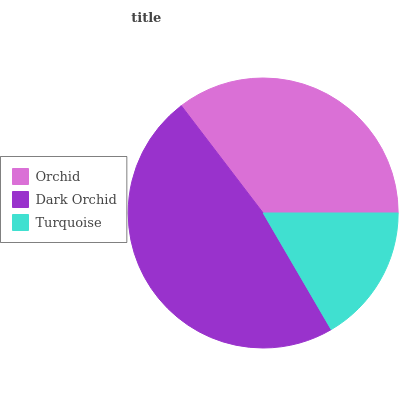Is Turquoise the minimum?
Answer yes or no. Yes. Is Dark Orchid the maximum?
Answer yes or no. Yes. Is Dark Orchid the minimum?
Answer yes or no. No. Is Turquoise the maximum?
Answer yes or no. No. Is Dark Orchid greater than Turquoise?
Answer yes or no. Yes. Is Turquoise less than Dark Orchid?
Answer yes or no. Yes. Is Turquoise greater than Dark Orchid?
Answer yes or no. No. Is Dark Orchid less than Turquoise?
Answer yes or no. No. Is Orchid the high median?
Answer yes or no. Yes. Is Orchid the low median?
Answer yes or no. Yes. Is Turquoise the high median?
Answer yes or no. No. Is Dark Orchid the low median?
Answer yes or no. No. 